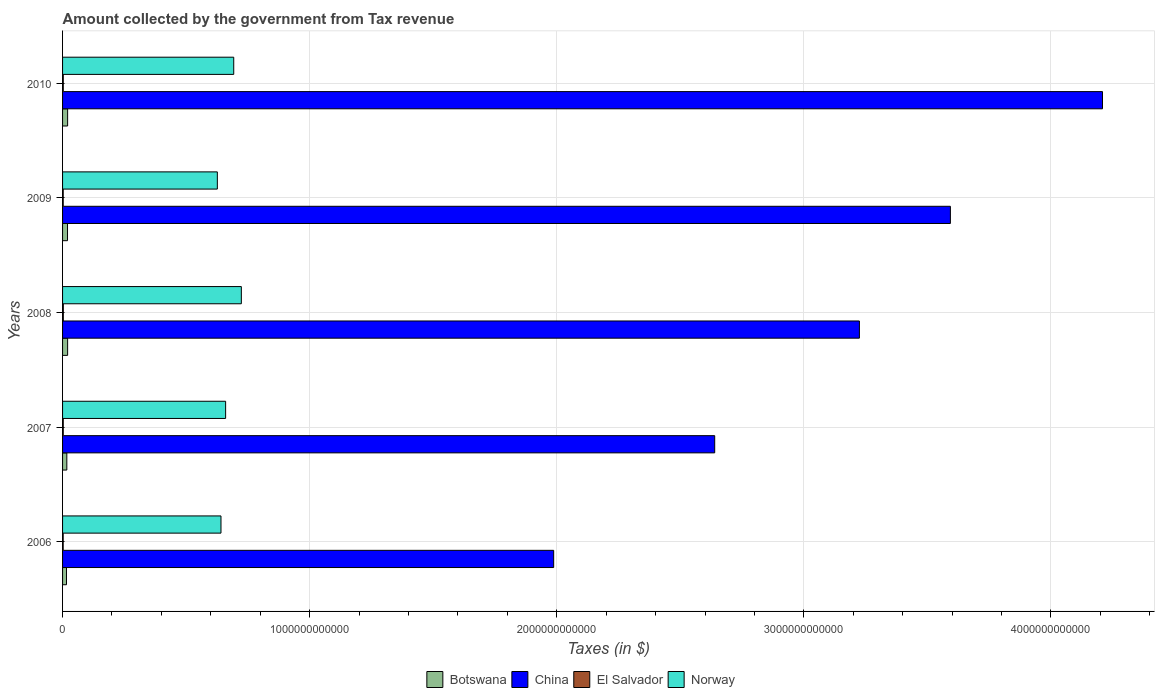How many different coloured bars are there?
Make the answer very short. 4. Are the number of bars per tick equal to the number of legend labels?
Keep it short and to the point. Yes. Are the number of bars on each tick of the Y-axis equal?
Provide a short and direct response. Yes. How many bars are there on the 5th tick from the top?
Ensure brevity in your answer.  4. How many bars are there on the 5th tick from the bottom?
Your answer should be very brief. 4. In how many cases, is the number of bars for a given year not equal to the number of legend labels?
Offer a very short reply. 0. What is the amount collected by the government from tax revenue in China in 2010?
Provide a succinct answer. 4.21e+12. Across all years, what is the maximum amount collected by the government from tax revenue in China?
Provide a succinct answer. 4.21e+12. Across all years, what is the minimum amount collected by the government from tax revenue in Norway?
Offer a very short reply. 6.26e+11. In which year was the amount collected by the government from tax revenue in El Salvador maximum?
Provide a short and direct response. 2008. What is the total amount collected by the government from tax revenue in China in the graph?
Provide a succinct answer. 1.57e+13. What is the difference between the amount collected by the government from tax revenue in China in 2008 and that in 2010?
Make the answer very short. -9.84e+11. What is the difference between the amount collected by the government from tax revenue in Botswana in 2006 and the amount collected by the government from tax revenue in El Salvador in 2008?
Ensure brevity in your answer.  1.29e+1. What is the average amount collected by the government from tax revenue in El Salvador per year?
Provide a short and direct response. 2.80e+09. In the year 2008, what is the difference between the amount collected by the government from tax revenue in Norway and amount collected by the government from tax revenue in Botswana?
Offer a very short reply. 7.03e+11. In how many years, is the amount collected by the government from tax revenue in China greater than 1000000000000 $?
Provide a succinct answer. 5. What is the ratio of the amount collected by the government from tax revenue in El Salvador in 2006 to that in 2009?
Ensure brevity in your answer.  0.95. What is the difference between the highest and the second highest amount collected by the government from tax revenue in El Salvador?
Keep it short and to the point. 1.52e+08. What is the difference between the highest and the lowest amount collected by the government from tax revenue in China?
Provide a succinct answer. 2.22e+12. Is it the case that in every year, the sum of the amount collected by the government from tax revenue in Botswana and amount collected by the government from tax revenue in El Salvador is greater than the sum of amount collected by the government from tax revenue in China and amount collected by the government from tax revenue in Norway?
Make the answer very short. No. What does the 2nd bar from the top in 2007 represents?
Your response must be concise. El Salvador. What does the 3rd bar from the bottom in 2009 represents?
Provide a short and direct response. El Salvador. Is it the case that in every year, the sum of the amount collected by the government from tax revenue in El Salvador and amount collected by the government from tax revenue in China is greater than the amount collected by the government from tax revenue in Botswana?
Your answer should be compact. Yes. How many bars are there?
Offer a terse response. 20. What is the difference between two consecutive major ticks on the X-axis?
Provide a succinct answer. 1.00e+12. Are the values on the major ticks of X-axis written in scientific E-notation?
Keep it short and to the point. No. Does the graph contain any zero values?
Offer a terse response. No. Does the graph contain grids?
Provide a short and direct response. Yes. How many legend labels are there?
Give a very brief answer. 4. What is the title of the graph?
Ensure brevity in your answer.  Amount collected by the government from Tax revenue. Does "Sub-Saharan Africa (developing only)" appear as one of the legend labels in the graph?
Keep it short and to the point. No. What is the label or title of the X-axis?
Your answer should be compact. Taxes (in $). What is the Taxes (in $) of Botswana in 2006?
Your answer should be very brief. 1.59e+1. What is the Taxes (in $) of China in 2006?
Ensure brevity in your answer.  1.99e+12. What is the Taxes (in $) of El Salvador in 2006?
Provide a succinct answer. 2.51e+09. What is the Taxes (in $) of Norway in 2006?
Your answer should be compact. 6.41e+11. What is the Taxes (in $) in Botswana in 2007?
Make the answer very short. 1.73e+1. What is the Taxes (in $) in China in 2007?
Provide a succinct answer. 2.64e+12. What is the Taxes (in $) of El Salvador in 2007?
Give a very brief answer. 2.85e+09. What is the Taxes (in $) in Norway in 2007?
Provide a succinct answer. 6.60e+11. What is the Taxes (in $) of Botswana in 2008?
Your answer should be compact. 2.05e+1. What is the Taxes (in $) of China in 2008?
Make the answer very short. 3.22e+12. What is the Taxes (in $) of El Salvador in 2008?
Offer a terse response. 3.07e+09. What is the Taxes (in $) of Norway in 2008?
Offer a terse response. 7.24e+11. What is the Taxes (in $) in Botswana in 2009?
Your answer should be very brief. 2.00e+1. What is the Taxes (in $) in China in 2009?
Give a very brief answer. 3.59e+12. What is the Taxes (in $) of El Salvador in 2009?
Offer a terse response. 2.64e+09. What is the Taxes (in $) of Norway in 2009?
Offer a terse response. 6.26e+11. What is the Taxes (in $) in Botswana in 2010?
Ensure brevity in your answer.  2.05e+1. What is the Taxes (in $) of China in 2010?
Ensure brevity in your answer.  4.21e+12. What is the Taxes (in $) of El Salvador in 2010?
Provide a succinct answer. 2.92e+09. What is the Taxes (in $) of Norway in 2010?
Provide a succinct answer. 6.93e+11. Across all years, what is the maximum Taxes (in $) of Botswana?
Ensure brevity in your answer.  2.05e+1. Across all years, what is the maximum Taxes (in $) in China?
Provide a succinct answer. 4.21e+12. Across all years, what is the maximum Taxes (in $) in El Salvador?
Ensure brevity in your answer.  3.07e+09. Across all years, what is the maximum Taxes (in $) in Norway?
Make the answer very short. 7.24e+11. Across all years, what is the minimum Taxes (in $) of Botswana?
Ensure brevity in your answer.  1.59e+1. Across all years, what is the minimum Taxes (in $) in China?
Make the answer very short. 1.99e+12. Across all years, what is the minimum Taxes (in $) in El Salvador?
Offer a very short reply. 2.51e+09. Across all years, what is the minimum Taxes (in $) in Norway?
Offer a terse response. 6.26e+11. What is the total Taxes (in $) of Botswana in the graph?
Offer a terse response. 9.42e+1. What is the total Taxes (in $) in China in the graph?
Provide a succinct answer. 1.57e+13. What is the total Taxes (in $) in El Salvador in the graph?
Offer a terse response. 1.40e+1. What is the total Taxes (in $) of Norway in the graph?
Provide a succinct answer. 3.34e+12. What is the difference between the Taxes (in $) of Botswana in 2006 and that in 2007?
Offer a very short reply. -1.35e+09. What is the difference between the Taxes (in $) in China in 2006 and that in 2007?
Keep it short and to the point. -6.52e+11. What is the difference between the Taxes (in $) in El Salvador in 2006 and that in 2007?
Offer a very short reply. -3.41e+08. What is the difference between the Taxes (in $) of Norway in 2006 and that in 2007?
Your answer should be compact. -1.88e+1. What is the difference between the Taxes (in $) of Botswana in 2006 and that in 2008?
Your answer should be very brief. -4.54e+09. What is the difference between the Taxes (in $) of China in 2006 and that in 2008?
Your response must be concise. -1.24e+12. What is the difference between the Taxes (in $) in El Salvador in 2006 and that in 2008?
Make the answer very short. -5.61e+08. What is the difference between the Taxes (in $) in Norway in 2006 and that in 2008?
Your answer should be very brief. -8.24e+1. What is the difference between the Taxes (in $) of Botswana in 2006 and that in 2009?
Give a very brief answer. -4.13e+09. What is the difference between the Taxes (in $) in China in 2006 and that in 2009?
Provide a short and direct response. -1.61e+12. What is the difference between the Taxes (in $) of El Salvador in 2006 and that in 2009?
Offer a terse response. -1.29e+08. What is the difference between the Taxes (in $) of Norway in 2006 and that in 2009?
Your answer should be very brief. 1.47e+1. What is the difference between the Taxes (in $) of Botswana in 2006 and that in 2010?
Make the answer very short. -4.59e+09. What is the difference between the Taxes (in $) in China in 2006 and that in 2010?
Your response must be concise. -2.22e+12. What is the difference between the Taxes (in $) in El Salvador in 2006 and that in 2010?
Give a very brief answer. -4.10e+08. What is the difference between the Taxes (in $) in Norway in 2006 and that in 2010?
Provide a short and direct response. -5.16e+1. What is the difference between the Taxes (in $) in Botswana in 2007 and that in 2008?
Provide a short and direct response. -3.19e+09. What is the difference between the Taxes (in $) in China in 2007 and that in 2008?
Provide a short and direct response. -5.86e+11. What is the difference between the Taxes (in $) of El Salvador in 2007 and that in 2008?
Your response must be concise. -2.20e+08. What is the difference between the Taxes (in $) of Norway in 2007 and that in 2008?
Your answer should be very brief. -6.36e+1. What is the difference between the Taxes (in $) in Botswana in 2007 and that in 2009?
Your answer should be very brief. -2.78e+09. What is the difference between the Taxes (in $) of China in 2007 and that in 2009?
Provide a short and direct response. -9.54e+11. What is the difference between the Taxes (in $) in El Salvador in 2007 and that in 2009?
Your answer should be very brief. 2.12e+08. What is the difference between the Taxes (in $) of Norway in 2007 and that in 2009?
Provide a short and direct response. 3.35e+1. What is the difference between the Taxes (in $) in Botswana in 2007 and that in 2010?
Keep it short and to the point. -3.24e+09. What is the difference between the Taxes (in $) of China in 2007 and that in 2010?
Offer a very short reply. -1.57e+12. What is the difference between the Taxes (in $) in El Salvador in 2007 and that in 2010?
Ensure brevity in your answer.  -6.84e+07. What is the difference between the Taxes (in $) in Norway in 2007 and that in 2010?
Your answer should be very brief. -3.28e+1. What is the difference between the Taxes (in $) of Botswana in 2008 and that in 2009?
Offer a very short reply. 4.09e+08. What is the difference between the Taxes (in $) of China in 2008 and that in 2009?
Offer a terse response. -3.68e+11. What is the difference between the Taxes (in $) in El Salvador in 2008 and that in 2009?
Provide a short and direct response. 4.32e+08. What is the difference between the Taxes (in $) of Norway in 2008 and that in 2009?
Make the answer very short. 9.71e+1. What is the difference between the Taxes (in $) of Botswana in 2008 and that in 2010?
Provide a short and direct response. -5.03e+07. What is the difference between the Taxes (in $) in China in 2008 and that in 2010?
Keep it short and to the point. -9.84e+11. What is the difference between the Taxes (in $) in El Salvador in 2008 and that in 2010?
Offer a very short reply. 1.52e+08. What is the difference between the Taxes (in $) in Norway in 2008 and that in 2010?
Offer a very short reply. 3.08e+1. What is the difference between the Taxes (in $) of Botswana in 2009 and that in 2010?
Offer a very short reply. -4.60e+08. What is the difference between the Taxes (in $) in China in 2009 and that in 2010?
Provide a short and direct response. -6.16e+11. What is the difference between the Taxes (in $) in El Salvador in 2009 and that in 2010?
Make the answer very short. -2.81e+08. What is the difference between the Taxes (in $) in Norway in 2009 and that in 2010?
Ensure brevity in your answer.  -6.63e+1. What is the difference between the Taxes (in $) of Botswana in 2006 and the Taxes (in $) of China in 2007?
Your answer should be compact. -2.62e+12. What is the difference between the Taxes (in $) of Botswana in 2006 and the Taxes (in $) of El Salvador in 2007?
Keep it short and to the point. 1.31e+1. What is the difference between the Taxes (in $) in Botswana in 2006 and the Taxes (in $) in Norway in 2007?
Make the answer very short. -6.44e+11. What is the difference between the Taxes (in $) of China in 2006 and the Taxes (in $) of El Salvador in 2007?
Provide a short and direct response. 1.98e+12. What is the difference between the Taxes (in $) of China in 2006 and the Taxes (in $) of Norway in 2007?
Your response must be concise. 1.33e+12. What is the difference between the Taxes (in $) of El Salvador in 2006 and the Taxes (in $) of Norway in 2007?
Your answer should be compact. -6.57e+11. What is the difference between the Taxes (in $) in Botswana in 2006 and the Taxes (in $) in China in 2008?
Your answer should be compact. -3.21e+12. What is the difference between the Taxes (in $) in Botswana in 2006 and the Taxes (in $) in El Salvador in 2008?
Provide a short and direct response. 1.29e+1. What is the difference between the Taxes (in $) in Botswana in 2006 and the Taxes (in $) in Norway in 2008?
Provide a succinct answer. -7.08e+11. What is the difference between the Taxes (in $) in China in 2006 and the Taxes (in $) in El Salvador in 2008?
Make the answer very short. 1.98e+12. What is the difference between the Taxes (in $) in China in 2006 and the Taxes (in $) in Norway in 2008?
Provide a succinct answer. 1.26e+12. What is the difference between the Taxes (in $) of El Salvador in 2006 and the Taxes (in $) of Norway in 2008?
Your answer should be very brief. -7.21e+11. What is the difference between the Taxes (in $) in Botswana in 2006 and the Taxes (in $) in China in 2009?
Make the answer very short. -3.58e+12. What is the difference between the Taxes (in $) of Botswana in 2006 and the Taxes (in $) of El Salvador in 2009?
Your response must be concise. 1.33e+1. What is the difference between the Taxes (in $) of Botswana in 2006 and the Taxes (in $) of Norway in 2009?
Your answer should be compact. -6.10e+11. What is the difference between the Taxes (in $) in China in 2006 and the Taxes (in $) in El Salvador in 2009?
Provide a short and direct response. 1.98e+12. What is the difference between the Taxes (in $) in China in 2006 and the Taxes (in $) in Norway in 2009?
Your response must be concise. 1.36e+12. What is the difference between the Taxes (in $) of El Salvador in 2006 and the Taxes (in $) of Norway in 2009?
Make the answer very short. -6.24e+11. What is the difference between the Taxes (in $) in Botswana in 2006 and the Taxes (in $) in China in 2010?
Ensure brevity in your answer.  -4.19e+12. What is the difference between the Taxes (in $) in Botswana in 2006 and the Taxes (in $) in El Salvador in 2010?
Keep it short and to the point. 1.30e+1. What is the difference between the Taxes (in $) of Botswana in 2006 and the Taxes (in $) of Norway in 2010?
Give a very brief answer. -6.77e+11. What is the difference between the Taxes (in $) in China in 2006 and the Taxes (in $) in El Salvador in 2010?
Ensure brevity in your answer.  1.98e+12. What is the difference between the Taxes (in $) of China in 2006 and the Taxes (in $) of Norway in 2010?
Ensure brevity in your answer.  1.29e+12. What is the difference between the Taxes (in $) in El Salvador in 2006 and the Taxes (in $) in Norway in 2010?
Offer a terse response. -6.90e+11. What is the difference between the Taxes (in $) of Botswana in 2007 and the Taxes (in $) of China in 2008?
Ensure brevity in your answer.  -3.21e+12. What is the difference between the Taxes (in $) in Botswana in 2007 and the Taxes (in $) in El Salvador in 2008?
Provide a short and direct response. 1.42e+1. What is the difference between the Taxes (in $) of Botswana in 2007 and the Taxes (in $) of Norway in 2008?
Provide a short and direct response. -7.06e+11. What is the difference between the Taxes (in $) in China in 2007 and the Taxes (in $) in El Salvador in 2008?
Your answer should be very brief. 2.64e+12. What is the difference between the Taxes (in $) in China in 2007 and the Taxes (in $) in Norway in 2008?
Your answer should be compact. 1.92e+12. What is the difference between the Taxes (in $) of El Salvador in 2007 and the Taxes (in $) of Norway in 2008?
Your answer should be compact. -7.21e+11. What is the difference between the Taxes (in $) in Botswana in 2007 and the Taxes (in $) in China in 2009?
Provide a short and direct response. -3.58e+12. What is the difference between the Taxes (in $) of Botswana in 2007 and the Taxes (in $) of El Salvador in 2009?
Ensure brevity in your answer.  1.46e+1. What is the difference between the Taxes (in $) in Botswana in 2007 and the Taxes (in $) in Norway in 2009?
Give a very brief answer. -6.09e+11. What is the difference between the Taxes (in $) in China in 2007 and the Taxes (in $) in El Salvador in 2009?
Give a very brief answer. 2.64e+12. What is the difference between the Taxes (in $) of China in 2007 and the Taxes (in $) of Norway in 2009?
Your answer should be compact. 2.01e+12. What is the difference between the Taxes (in $) of El Salvador in 2007 and the Taxes (in $) of Norway in 2009?
Your answer should be compact. -6.24e+11. What is the difference between the Taxes (in $) of Botswana in 2007 and the Taxes (in $) of China in 2010?
Keep it short and to the point. -4.19e+12. What is the difference between the Taxes (in $) of Botswana in 2007 and the Taxes (in $) of El Salvador in 2010?
Give a very brief answer. 1.43e+1. What is the difference between the Taxes (in $) of Botswana in 2007 and the Taxes (in $) of Norway in 2010?
Your answer should be compact. -6.75e+11. What is the difference between the Taxes (in $) of China in 2007 and the Taxes (in $) of El Salvador in 2010?
Keep it short and to the point. 2.64e+12. What is the difference between the Taxes (in $) in China in 2007 and the Taxes (in $) in Norway in 2010?
Your answer should be compact. 1.95e+12. What is the difference between the Taxes (in $) in El Salvador in 2007 and the Taxes (in $) in Norway in 2010?
Your answer should be very brief. -6.90e+11. What is the difference between the Taxes (in $) in Botswana in 2008 and the Taxes (in $) in China in 2009?
Provide a succinct answer. -3.57e+12. What is the difference between the Taxes (in $) in Botswana in 2008 and the Taxes (in $) in El Salvador in 2009?
Make the answer very short. 1.78e+1. What is the difference between the Taxes (in $) of Botswana in 2008 and the Taxes (in $) of Norway in 2009?
Ensure brevity in your answer.  -6.06e+11. What is the difference between the Taxes (in $) in China in 2008 and the Taxes (in $) in El Salvador in 2009?
Provide a short and direct response. 3.22e+12. What is the difference between the Taxes (in $) in China in 2008 and the Taxes (in $) in Norway in 2009?
Make the answer very short. 2.60e+12. What is the difference between the Taxes (in $) in El Salvador in 2008 and the Taxes (in $) in Norway in 2009?
Give a very brief answer. -6.23e+11. What is the difference between the Taxes (in $) in Botswana in 2008 and the Taxes (in $) in China in 2010?
Offer a very short reply. -4.19e+12. What is the difference between the Taxes (in $) in Botswana in 2008 and the Taxes (in $) in El Salvador in 2010?
Your answer should be very brief. 1.75e+1. What is the difference between the Taxes (in $) of Botswana in 2008 and the Taxes (in $) of Norway in 2010?
Your response must be concise. -6.72e+11. What is the difference between the Taxes (in $) in China in 2008 and the Taxes (in $) in El Salvador in 2010?
Make the answer very short. 3.22e+12. What is the difference between the Taxes (in $) in China in 2008 and the Taxes (in $) in Norway in 2010?
Make the answer very short. 2.53e+12. What is the difference between the Taxes (in $) in El Salvador in 2008 and the Taxes (in $) in Norway in 2010?
Keep it short and to the point. -6.90e+11. What is the difference between the Taxes (in $) in Botswana in 2009 and the Taxes (in $) in China in 2010?
Offer a terse response. -4.19e+12. What is the difference between the Taxes (in $) of Botswana in 2009 and the Taxes (in $) of El Salvador in 2010?
Offer a terse response. 1.71e+1. What is the difference between the Taxes (in $) in Botswana in 2009 and the Taxes (in $) in Norway in 2010?
Provide a short and direct response. -6.73e+11. What is the difference between the Taxes (in $) in China in 2009 and the Taxes (in $) in El Salvador in 2010?
Ensure brevity in your answer.  3.59e+12. What is the difference between the Taxes (in $) in China in 2009 and the Taxes (in $) in Norway in 2010?
Give a very brief answer. 2.90e+12. What is the difference between the Taxes (in $) in El Salvador in 2009 and the Taxes (in $) in Norway in 2010?
Ensure brevity in your answer.  -6.90e+11. What is the average Taxes (in $) in Botswana per year?
Provide a short and direct response. 1.88e+1. What is the average Taxes (in $) in China per year?
Offer a terse response. 3.13e+12. What is the average Taxes (in $) in El Salvador per year?
Provide a short and direct response. 2.80e+09. What is the average Taxes (in $) of Norway per year?
Your answer should be compact. 6.69e+11. In the year 2006, what is the difference between the Taxes (in $) in Botswana and Taxes (in $) in China?
Your answer should be very brief. -1.97e+12. In the year 2006, what is the difference between the Taxes (in $) of Botswana and Taxes (in $) of El Salvador?
Offer a terse response. 1.34e+1. In the year 2006, what is the difference between the Taxes (in $) in Botswana and Taxes (in $) in Norway?
Your answer should be very brief. -6.25e+11. In the year 2006, what is the difference between the Taxes (in $) of China and Taxes (in $) of El Salvador?
Your response must be concise. 1.99e+12. In the year 2006, what is the difference between the Taxes (in $) of China and Taxes (in $) of Norway?
Offer a terse response. 1.35e+12. In the year 2006, what is the difference between the Taxes (in $) in El Salvador and Taxes (in $) in Norway?
Your answer should be compact. -6.39e+11. In the year 2007, what is the difference between the Taxes (in $) of Botswana and Taxes (in $) of China?
Provide a succinct answer. -2.62e+12. In the year 2007, what is the difference between the Taxes (in $) in Botswana and Taxes (in $) in El Salvador?
Provide a short and direct response. 1.44e+1. In the year 2007, what is the difference between the Taxes (in $) in Botswana and Taxes (in $) in Norway?
Make the answer very short. -6.43e+11. In the year 2007, what is the difference between the Taxes (in $) of China and Taxes (in $) of El Salvador?
Your answer should be compact. 2.64e+12. In the year 2007, what is the difference between the Taxes (in $) of China and Taxes (in $) of Norway?
Give a very brief answer. 1.98e+12. In the year 2007, what is the difference between the Taxes (in $) of El Salvador and Taxes (in $) of Norway?
Your answer should be very brief. -6.57e+11. In the year 2008, what is the difference between the Taxes (in $) in Botswana and Taxes (in $) in China?
Your response must be concise. -3.20e+12. In the year 2008, what is the difference between the Taxes (in $) of Botswana and Taxes (in $) of El Salvador?
Give a very brief answer. 1.74e+1. In the year 2008, what is the difference between the Taxes (in $) in Botswana and Taxes (in $) in Norway?
Offer a very short reply. -7.03e+11. In the year 2008, what is the difference between the Taxes (in $) in China and Taxes (in $) in El Salvador?
Your answer should be very brief. 3.22e+12. In the year 2008, what is the difference between the Taxes (in $) of China and Taxes (in $) of Norway?
Keep it short and to the point. 2.50e+12. In the year 2008, what is the difference between the Taxes (in $) of El Salvador and Taxes (in $) of Norway?
Give a very brief answer. -7.20e+11. In the year 2009, what is the difference between the Taxes (in $) of Botswana and Taxes (in $) of China?
Give a very brief answer. -3.57e+12. In the year 2009, what is the difference between the Taxes (in $) in Botswana and Taxes (in $) in El Salvador?
Provide a succinct answer. 1.74e+1. In the year 2009, what is the difference between the Taxes (in $) of Botswana and Taxes (in $) of Norway?
Provide a succinct answer. -6.06e+11. In the year 2009, what is the difference between the Taxes (in $) of China and Taxes (in $) of El Salvador?
Your answer should be very brief. 3.59e+12. In the year 2009, what is the difference between the Taxes (in $) in China and Taxes (in $) in Norway?
Your answer should be very brief. 2.97e+12. In the year 2009, what is the difference between the Taxes (in $) of El Salvador and Taxes (in $) of Norway?
Ensure brevity in your answer.  -6.24e+11. In the year 2010, what is the difference between the Taxes (in $) in Botswana and Taxes (in $) in China?
Give a very brief answer. -4.19e+12. In the year 2010, what is the difference between the Taxes (in $) of Botswana and Taxes (in $) of El Salvador?
Make the answer very short. 1.76e+1. In the year 2010, what is the difference between the Taxes (in $) of Botswana and Taxes (in $) of Norway?
Your answer should be very brief. -6.72e+11. In the year 2010, what is the difference between the Taxes (in $) of China and Taxes (in $) of El Salvador?
Keep it short and to the point. 4.21e+12. In the year 2010, what is the difference between the Taxes (in $) of China and Taxes (in $) of Norway?
Your answer should be compact. 3.52e+12. In the year 2010, what is the difference between the Taxes (in $) of El Salvador and Taxes (in $) of Norway?
Give a very brief answer. -6.90e+11. What is the ratio of the Taxes (in $) of Botswana in 2006 to that in 2007?
Ensure brevity in your answer.  0.92. What is the ratio of the Taxes (in $) in China in 2006 to that in 2007?
Keep it short and to the point. 0.75. What is the ratio of the Taxes (in $) in El Salvador in 2006 to that in 2007?
Give a very brief answer. 0.88. What is the ratio of the Taxes (in $) of Norway in 2006 to that in 2007?
Ensure brevity in your answer.  0.97. What is the ratio of the Taxes (in $) of Botswana in 2006 to that in 2008?
Provide a short and direct response. 0.78. What is the ratio of the Taxes (in $) of China in 2006 to that in 2008?
Keep it short and to the point. 0.62. What is the ratio of the Taxes (in $) of El Salvador in 2006 to that in 2008?
Provide a succinct answer. 0.82. What is the ratio of the Taxes (in $) of Norway in 2006 to that in 2008?
Provide a short and direct response. 0.89. What is the ratio of the Taxes (in $) in Botswana in 2006 to that in 2009?
Offer a terse response. 0.79. What is the ratio of the Taxes (in $) in China in 2006 to that in 2009?
Your answer should be very brief. 0.55. What is the ratio of the Taxes (in $) of El Salvador in 2006 to that in 2009?
Keep it short and to the point. 0.95. What is the ratio of the Taxes (in $) in Norway in 2006 to that in 2009?
Make the answer very short. 1.02. What is the ratio of the Taxes (in $) in Botswana in 2006 to that in 2010?
Provide a short and direct response. 0.78. What is the ratio of the Taxes (in $) in China in 2006 to that in 2010?
Your answer should be compact. 0.47. What is the ratio of the Taxes (in $) in El Salvador in 2006 to that in 2010?
Give a very brief answer. 0.86. What is the ratio of the Taxes (in $) of Norway in 2006 to that in 2010?
Your answer should be very brief. 0.93. What is the ratio of the Taxes (in $) in Botswana in 2007 to that in 2008?
Offer a terse response. 0.84. What is the ratio of the Taxes (in $) of China in 2007 to that in 2008?
Your answer should be compact. 0.82. What is the ratio of the Taxes (in $) in El Salvador in 2007 to that in 2008?
Provide a short and direct response. 0.93. What is the ratio of the Taxes (in $) of Norway in 2007 to that in 2008?
Make the answer very short. 0.91. What is the ratio of the Taxes (in $) of Botswana in 2007 to that in 2009?
Your answer should be compact. 0.86. What is the ratio of the Taxes (in $) of China in 2007 to that in 2009?
Offer a very short reply. 0.73. What is the ratio of the Taxes (in $) in El Salvador in 2007 to that in 2009?
Ensure brevity in your answer.  1.08. What is the ratio of the Taxes (in $) of Norway in 2007 to that in 2009?
Your answer should be very brief. 1.05. What is the ratio of the Taxes (in $) in Botswana in 2007 to that in 2010?
Make the answer very short. 0.84. What is the ratio of the Taxes (in $) of China in 2007 to that in 2010?
Provide a short and direct response. 0.63. What is the ratio of the Taxes (in $) in El Salvador in 2007 to that in 2010?
Keep it short and to the point. 0.98. What is the ratio of the Taxes (in $) in Norway in 2007 to that in 2010?
Keep it short and to the point. 0.95. What is the ratio of the Taxes (in $) in Botswana in 2008 to that in 2009?
Offer a terse response. 1.02. What is the ratio of the Taxes (in $) in China in 2008 to that in 2009?
Ensure brevity in your answer.  0.9. What is the ratio of the Taxes (in $) of El Salvador in 2008 to that in 2009?
Offer a terse response. 1.16. What is the ratio of the Taxes (in $) in Norway in 2008 to that in 2009?
Keep it short and to the point. 1.16. What is the ratio of the Taxes (in $) of China in 2008 to that in 2010?
Keep it short and to the point. 0.77. What is the ratio of the Taxes (in $) in El Salvador in 2008 to that in 2010?
Give a very brief answer. 1.05. What is the ratio of the Taxes (in $) of Norway in 2008 to that in 2010?
Ensure brevity in your answer.  1.04. What is the ratio of the Taxes (in $) in Botswana in 2009 to that in 2010?
Ensure brevity in your answer.  0.98. What is the ratio of the Taxes (in $) of China in 2009 to that in 2010?
Your response must be concise. 0.85. What is the ratio of the Taxes (in $) in El Salvador in 2009 to that in 2010?
Your answer should be very brief. 0.9. What is the ratio of the Taxes (in $) in Norway in 2009 to that in 2010?
Provide a succinct answer. 0.9. What is the difference between the highest and the second highest Taxes (in $) in Botswana?
Provide a succinct answer. 5.03e+07. What is the difference between the highest and the second highest Taxes (in $) of China?
Make the answer very short. 6.16e+11. What is the difference between the highest and the second highest Taxes (in $) of El Salvador?
Provide a succinct answer. 1.52e+08. What is the difference between the highest and the second highest Taxes (in $) of Norway?
Offer a very short reply. 3.08e+1. What is the difference between the highest and the lowest Taxes (in $) in Botswana?
Offer a terse response. 4.59e+09. What is the difference between the highest and the lowest Taxes (in $) in China?
Your response must be concise. 2.22e+12. What is the difference between the highest and the lowest Taxes (in $) in El Salvador?
Your answer should be compact. 5.61e+08. What is the difference between the highest and the lowest Taxes (in $) of Norway?
Ensure brevity in your answer.  9.71e+1. 